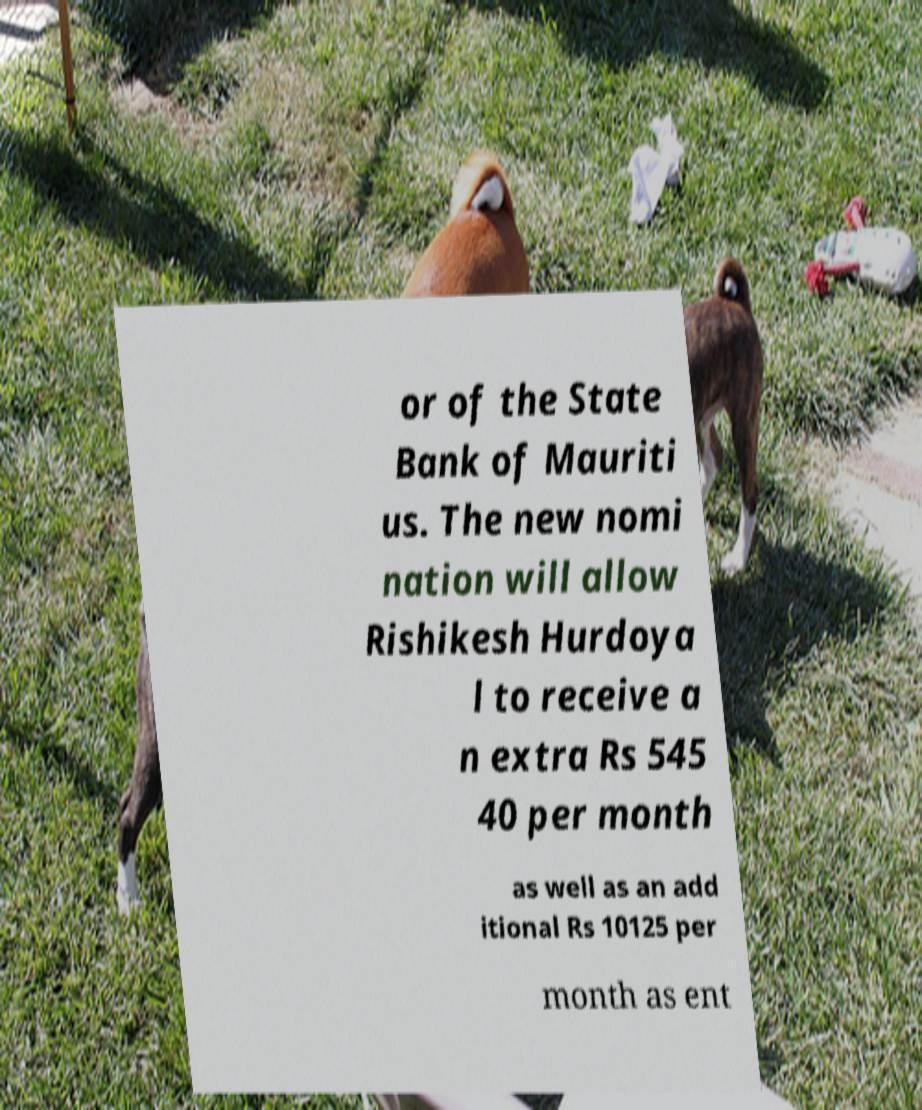Please identify and transcribe the text found in this image. or of the State Bank of Mauriti us. The new nomi nation will allow Rishikesh Hurdoya l to receive a n extra Rs 545 40 per month as well as an add itional Rs 10125 per month as ent 